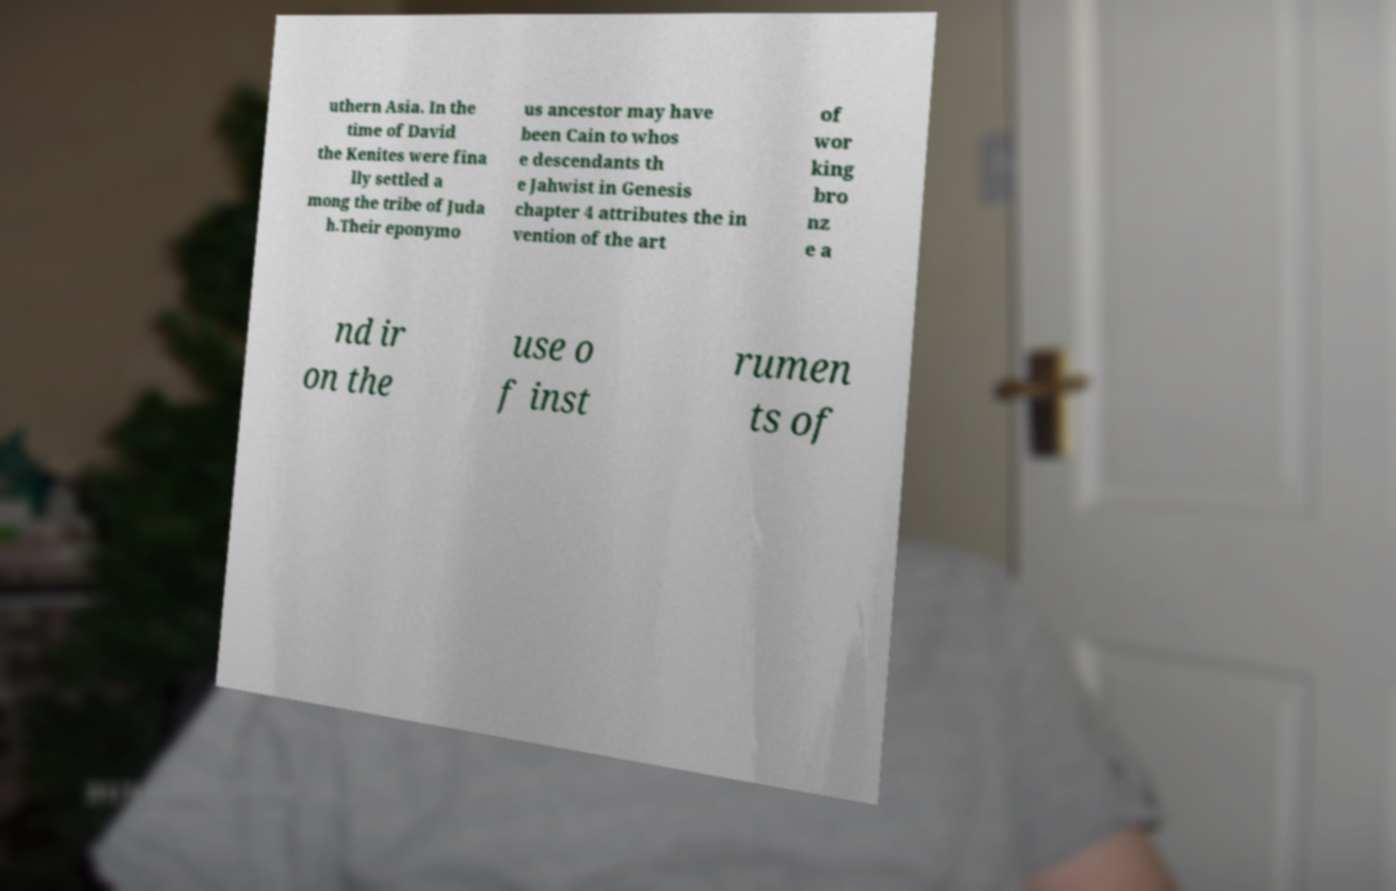I need the written content from this picture converted into text. Can you do that? uthern Asia. In the time of David the Kenites were fina lly settled a mong the tribe of Juda h.Their eponymo us ancestor may have been Cain to whos e descendants th e Jahwist in Genesis chapter 4 attributes the in vention of the art of wor king bro nz e a nd ir on the use o f inst rumen ts of 